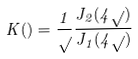<formula> <loc_0><loc_0><loc_500><loc_500>K ( \L ) = \frac { 1 } { \sqrt { \L } } \frac { J _ { 2 } ( 4 \sqrt { \L } ) } { J _ { 1 } ( 4 \sqrt { \L } ) }</formula> 